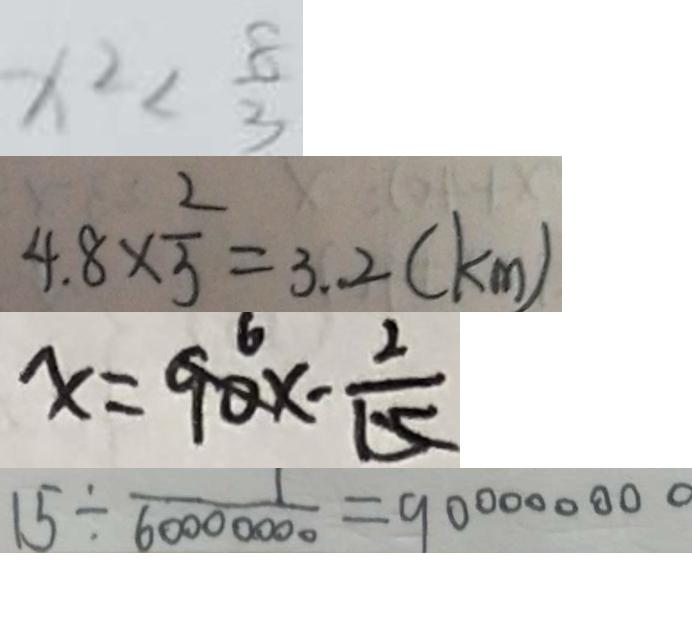Convert formula to latex. <formula><loc_0><loc_0><loc_500><loc_500>x ^ { 2 } < \frac { 8 } { 3 } 
 4 . 8 \times \frac { 2 } { 3 } = 3 . 2 ( k m ) 
 x = 9 0 x - \frac { 2 } { 1 5 } 
 1 5 \div \frac { 1 } { 6 0 0 0 0 0 0 0 } = 9 0 0 0 0 0 0 0 0</formula> 